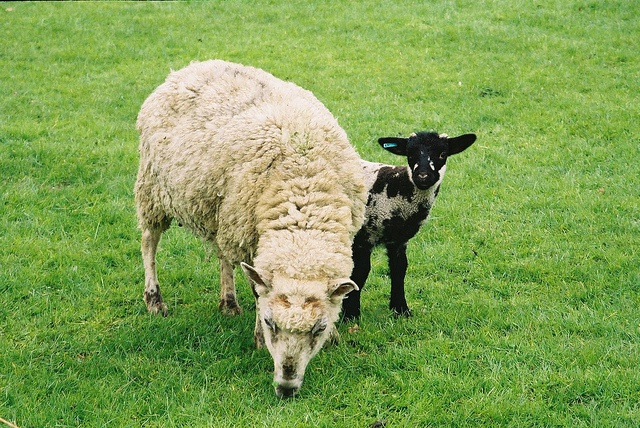Describe the objects in this image and their specific colors. I can see sheep in black, tan, and lightgray tones and sheep in black, gray, darkgray, and olive tones in this image. 